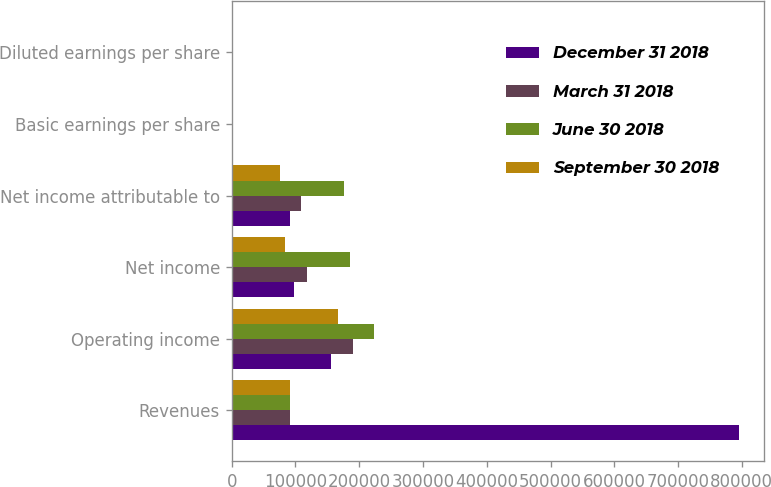<chart> <loc_0><loc_0><loc_500><loc_500><stacked_bar_chart><ecel><fcel>Revenues<fcel>Operating income<fcel>Net income<fcel>Net income attributable to<fcel>Basic earnings per share<fcel>Diluted earnings per share<nl><fcel>December 31 2018<fcel>794977<fcel>156170<fcel>97586<fcel>91399<fcel>0.57<fcel>0.57<nl><fcel>March 31 2018<fcel>91399<fcel>190737<fcel>117729<fcel>109069<fcel>0.69<fcel>0.68<nl><fcel>June 30 2018<fcel>91399<fcel>223162<fcel>186029<fcel>176370<fcel>1.12<fcel>1.11<nl><fcel>September 30 2018<fcel>91399<fcel>166986<fcel>83323<fcel>75215<fcel>0.48<fcel>0.47<nl></chart> 